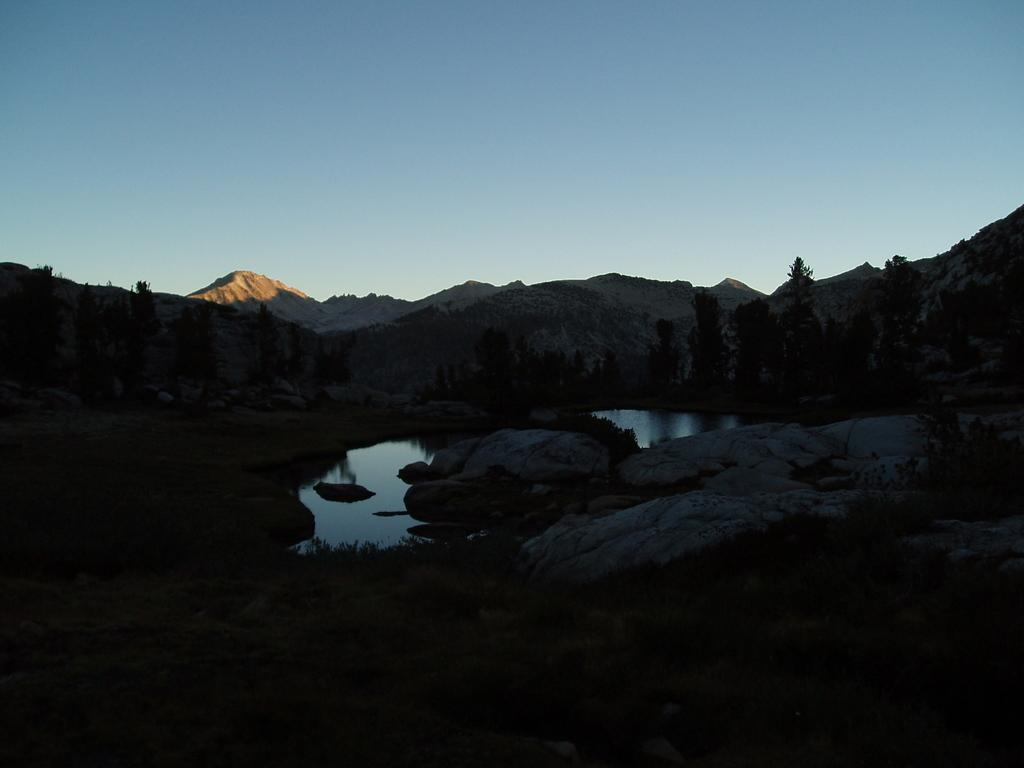What type of terrain is visible at the bottom of the image? There is green grass at the bottom of the image. What objects can be seen in the foreground of the image? There are rocks and water in the foreground of the image. What type of vegetation is visible in the background of the image? There are trees in the background of the image. What geographical features can be seen in the background of the image? There are mountains in the background of the image. What part of the natural environment is visible at the top of the image? The sky is visible at the top of the image. Can you see any scissors being used in the image? There are no scissors present in the image. Is there a boat visible in the image? There is no boat present in the image. Are there any deer visible in the image? There are no deer present in the image. 